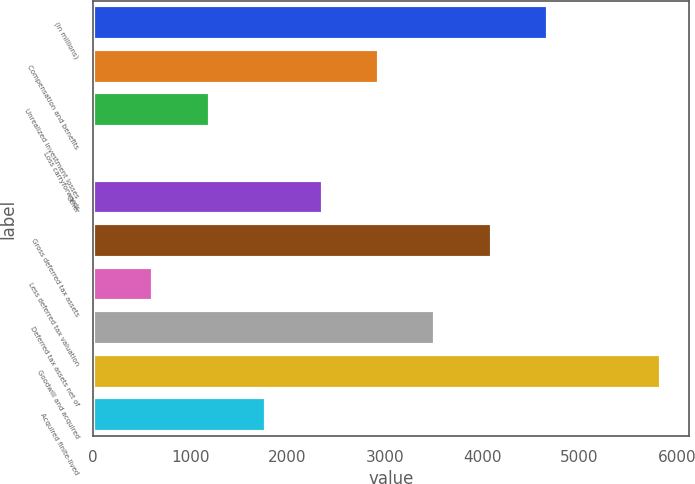Convert chart to OTSL. <chart><loc_0><loc_0><loc_500><loc_500><bar_chart><fcel>(in millions)<fcel>Compensation and benefits<fcel>Unrealized investment losses<fcel>Loss carryforwards<fcel>Other<fcel>Gross deferred tax assets<fcel>Less deferred tax valuation<fcel>Deferred tax assets net of<fcel>Goodwill and acquired<fcel>Acquired finite-lived<nl><fcel>4678<fcel>2939.5<fcel>1201<fcel>42<fcel>2360<fcel>4098.5<fcel>621.5<fcel>3519<fcel>5837<fcel>1780.5<nl></chart> 